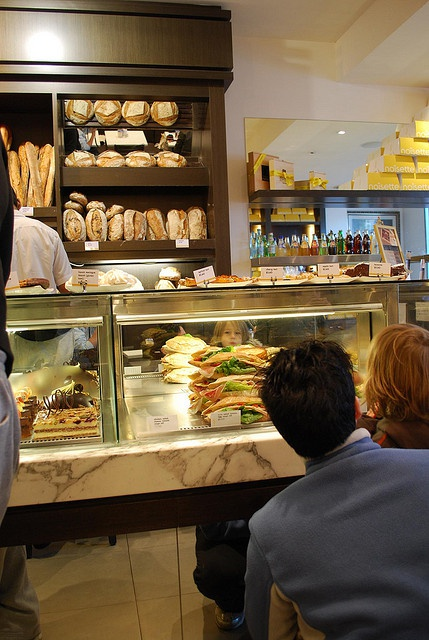Describe the objects in this image and their specific colors. I can see people in olive, black, gray, and maroon tones, people in olive, black, and gray tones, people in olive, maroon, black, and brown tones, people in olive, darkgray, and tan tones, and cake in olive, tan, and maroon tones in this image. 